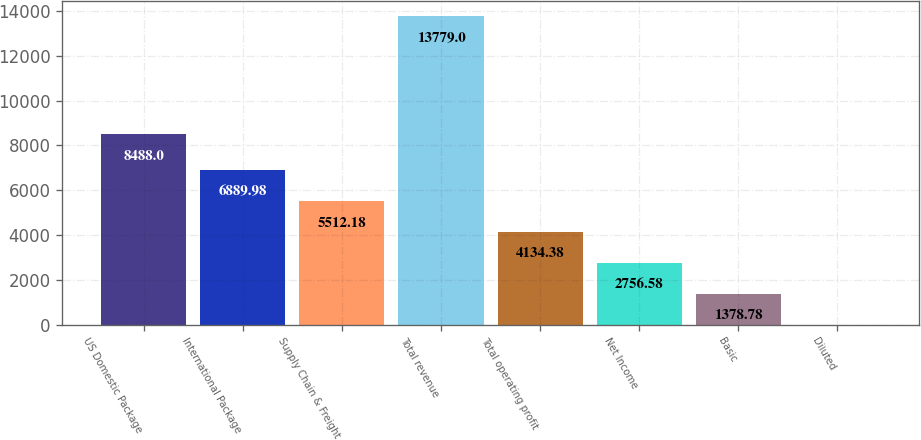Convert chart to OTSL. <chart><loc_0><loc_0><loc_500><loc_500><bar_chart><fcel>US Domestic Package<fcel>International Package<fcel>Supply Chain & Freight<fcel>Total revenue<fcel>Total operating profit<fcel>Net Income<fcel>Basic<fcel>Diluted<nl><fcel>8488<fcel>6889.98<fcel>5512.18<fcel>13779<fcel>4134.38<fcel>2756.58<fcel>1378.78<fcel>0.98<nl></chart> 